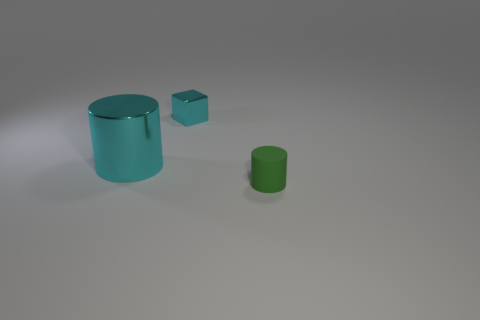Are there any objects of the same color as the block?
Ensure brevity in your answer.  Yes. What is the size of the cyan object that is the same shape as the green object?
Offer a terse response. Large. There is a metallic object that is the same color as the block; what is its shape?
Ensure brevity in your answer.  Cylinder. What number of green rubber cylinders are left of the cylinder that is left of the rubber cylinder?
Your answer should be compact. 0. There is a cylinder in front of the cyan cylinder; does it have the same size as the cyan block?
Give a very brief answer. Yes. What number of cyan metal objects have the same shape as the matte object?
Make the answer very short. 1. What is the shape of the big metallic thing?
Your answer should be compact. Cylinder. Is the number of green things to the right of the green rubber thing the same as the number of green cylinders?
Your answer should be compact. No. Is there any other thing that has the same material as the big cyan cylinder?
Ensure brevity in your answer.  Yes. Are the cyan thing behind the big cylinder and the small cylinder made of the same material?
Provide a succinct answer. No. 